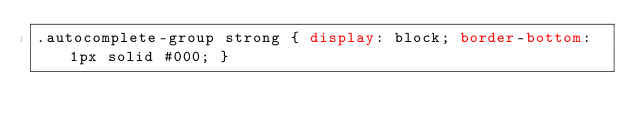<code> <loc_0><loc_0><loc_500><loc_500><_CSS_>.autocomplete-group strong { display: block; border-bottom: 1px solid #000; }

</code> 